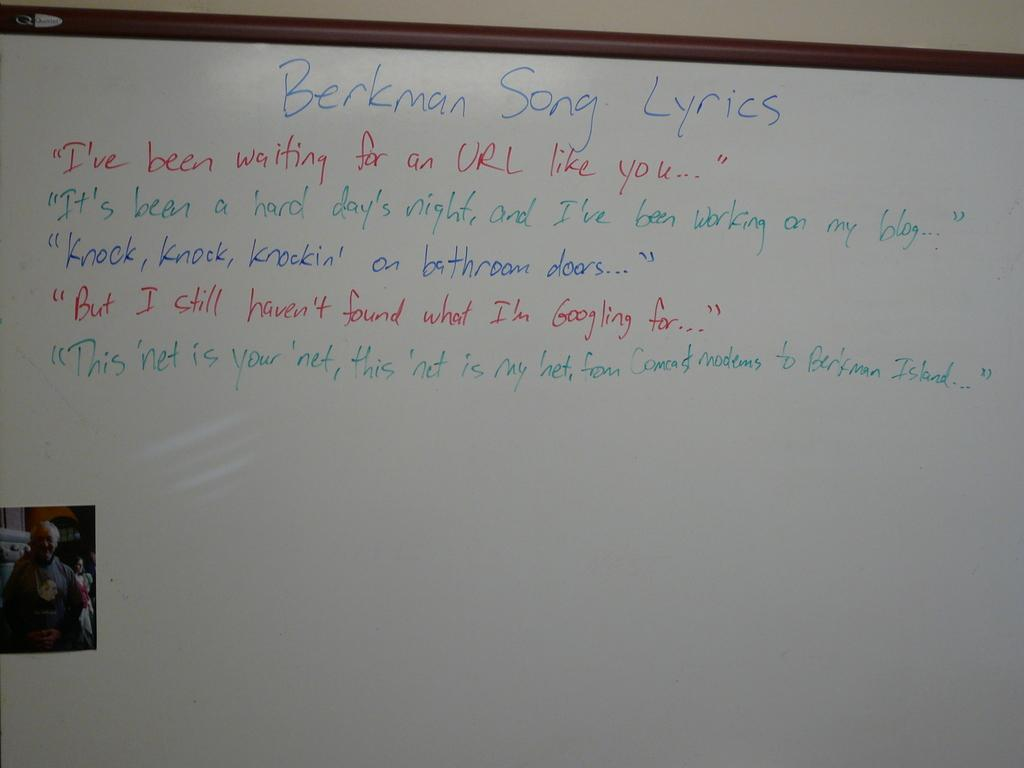<image>
Describe the image concisely. A whiteboard  with the Berkman song lyrics written in different colors. 